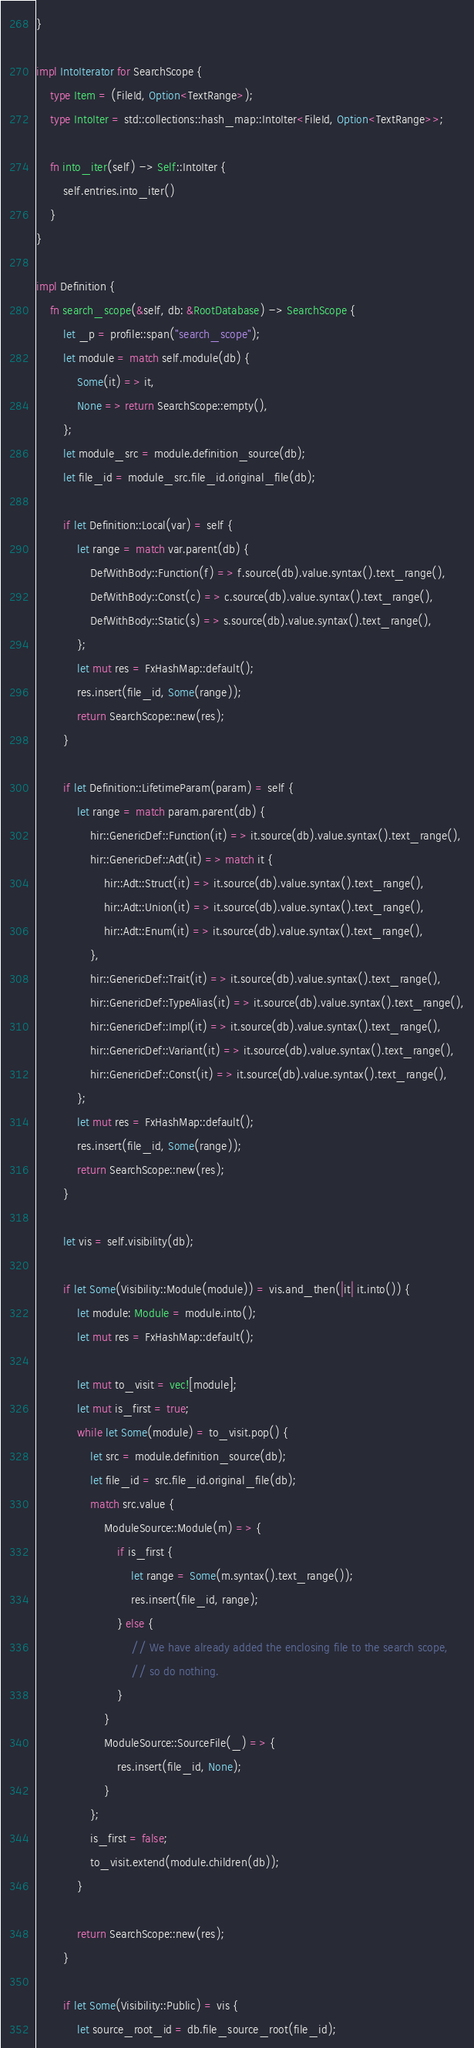<code> <loc_0><loc_0><loc_500><loc_500><_Rust_>}

impl IntoIterator for SearchScope {
    type Item = (FileId, Option<TextRange>);
    type IntoIter = std::collections::hash_map::IntoIter<FileId, Option<TextRange>>;

    fn into_iter(self) -> Self::IntoIter {
        self.entries.into_iter()
    }
}

impl Definition {
    fn search_scope(&self, db: &RootDatabase) -> SearchScope {
        let _p = profile::span("search_scope");
        let module = match self.module(db) {
            Some(it) => it,
            None => return SearchScope::empty(),
        };
        let module_src = module.definition_source(db);
        let file_id = module_src.file_id.original_file(db);

        if let Definition::Local(var) = self {
            let range = match var.parent(db) {
                DefWithBody::Function(f) => f.source(db).value.syntax().text_range(),
                DefWithBody::Const(c) => c.source(db).value.syntax().text_range(),
                DefWithBody::Static(s) => s.source(db).value.syntax().text_range(),
            };
            let mut res = FxHashMap::default();
            res.insert(file_id, Some(range));
            return SearchScope::new(res);
        }

        if let Definition::LifetimeParam(param) = self {
            let range = match param.parent(db) {
                hir::GenericDef::Function(it) => it.source(db).value.syntax().text_range(),
                hir::GenericDef::Adt(it) => match it {
                    hir::Adt::Struct(it) => it.source(db).value.syntax().text_range(),
                    hir::Adt::Union(it) => it.source(db).value.syntax().text_range(),
                    hir::Adt::Enum(it) => it.source(db).value.syntax().text_range(),
                },
                hir::GenericDef::Trait(it) => it.source(db).value.syntax().text_range(),
                hir::GenericDef::TypeAlias(it) => it.source(db).value.syntax().text_range(),
                hir::GenericDef::Impl(it) => it.source(db).value.syntax().text_range(),
                hir::GenericDef::Variant(it) => it.source(db).value.syntax().text_range(),
                hir::GenericDef::Const(it) => it.source(db).value.syntax().text_range(),
            };
            let mut res = FxHashMap::default();
            res.insert(file_id, Some(range));
            return SearchScope::new(res);
        }

        let vis = self.visibility(db);

        if let Some(Visibility::Module(module)) = vis.and_then(|it| it.into()) {
            let module: Module = module.into();
            let mut res = FxHashMap::default();

            let mut to_visit = vec![module];
            let mut is_first = true;
            while let Some(module) = to_visit.pop() {
                let src = module.definition_source(db);
                let file_id = src.file_id.original_file(db);
                match src.value {
                    ModuleSource::Module(m) => {
                        if is_first {
                            let range = Some(m.syntax().text_range());
                            res.insert(file_id, range);
                        } else {
                            // We have already added the enclosing file to the search scope,
                            // so do nothing.
                        }
                    }
                    ModuleSource::SourceFile(_) => {
                        res.insert(file_id, None);
                    }
                };
                is_first = false;
                to_visit.extend(module.children(db));
            }

            return SearchScope::new(res);
        }

        if let Some(Visibility::Public) = vis {
            let source_root_id = db.file_source_root(file_id);</code> 